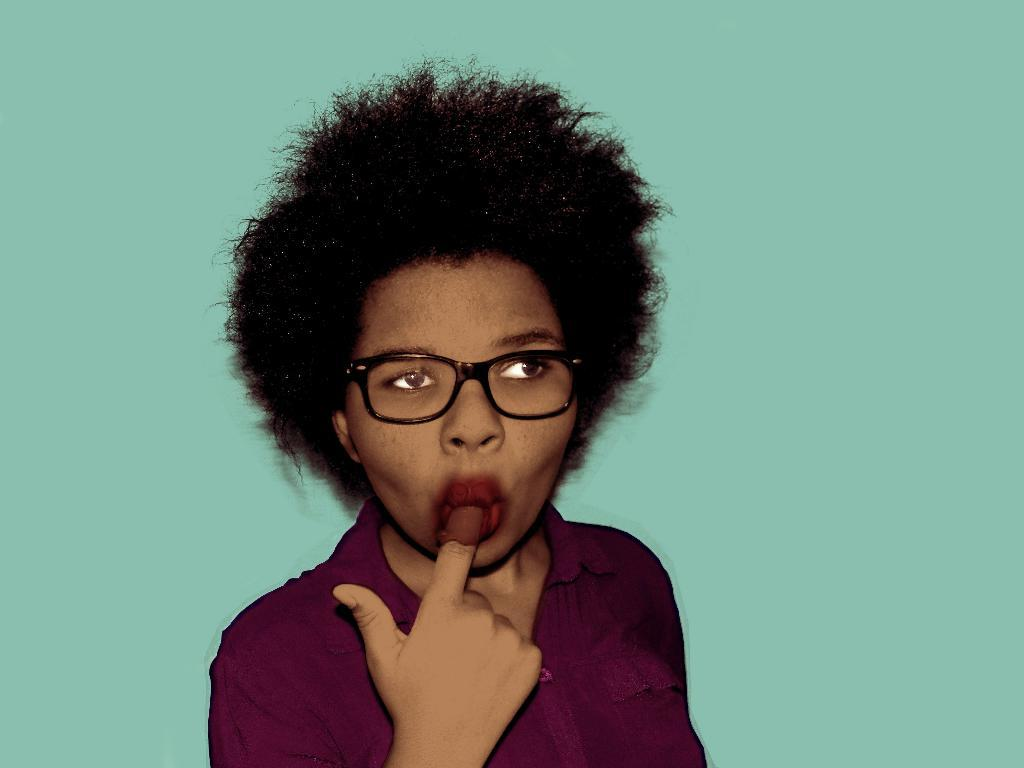What is the main subject of the image? There is a person standing in the center of the image. Can you describe the background of the image? There is a wall in the background of the image. What type of shoes is the person's aunt wearing in the image? There is no mention of shoes or an aunt in the image, so it is not possible to answer that question. 